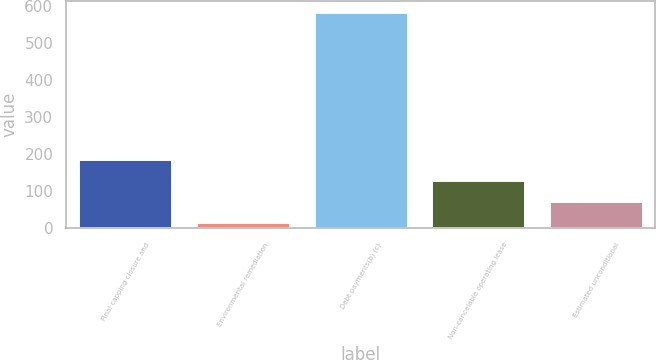<chart> <loc_0><loc_0><loc_500><loc_500><bar_chart><fcel>Final capping closure and<fcel>Environmental remediation<fcel>Debt payments(b) (c)<fcel>Non-cancelable operating lease<fcel>Estimated unconditional<nl><fcel>187.5<fcel>18<fcel>583<fcel>131<fcel>74.5<nl></chart> 